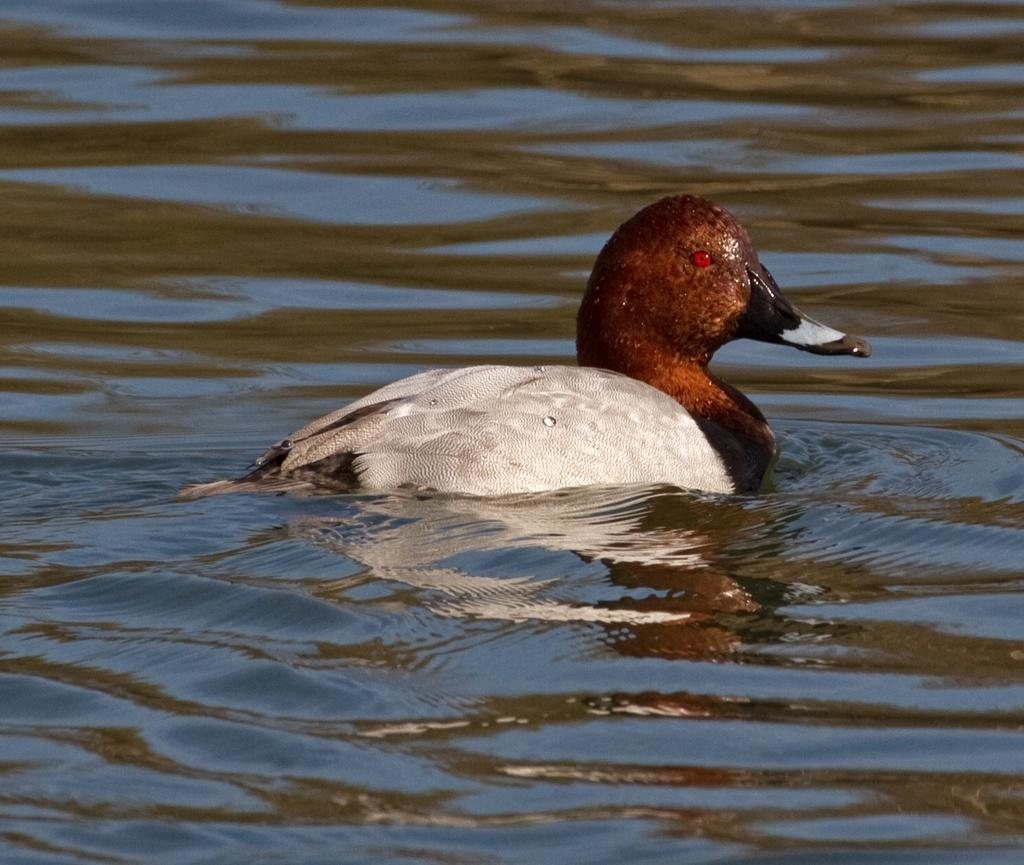What animal is present in the image? There is a duck in the image. What is the duck doing in the image? The duck is swimming in the water. What type of lunch is being served on the ship in the image? There is no ship or lunch present in the image; it features a duck swimming in the water. 